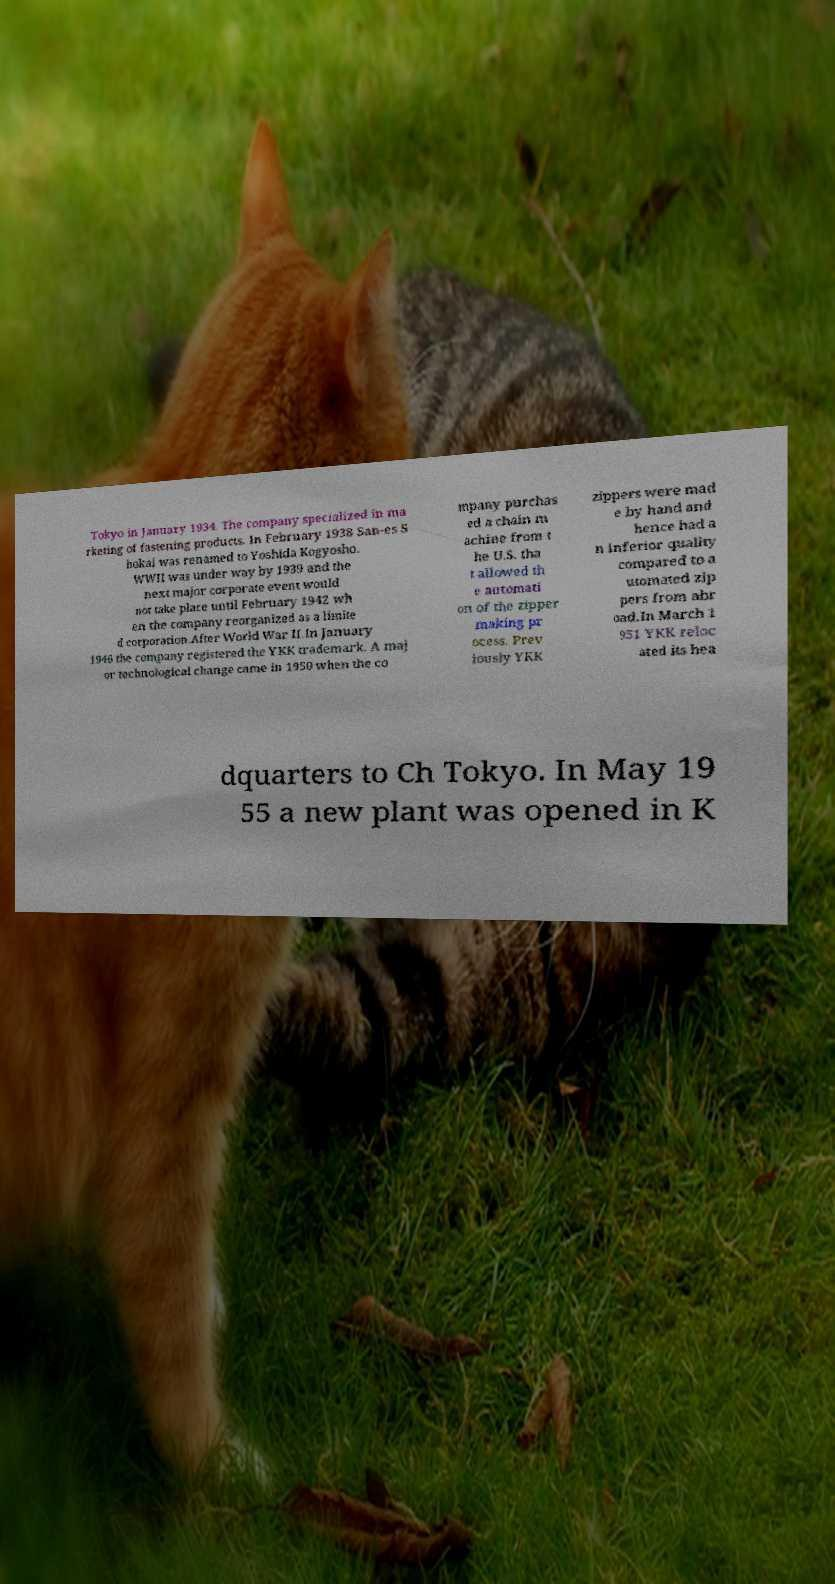Please read and relay the text visible in this image. What does it say? Tokyo in January 1934. The company specialized in ma rketing of fastening products. In February 1938 San-es S hokai was renamed to Yoshida Kogyosho. WWII was under way by 1939 and the next major corporate event would not take place until February 1942 wh en the company reorganized as a limite d corporation.After World War II.In January 1946 the company registered the YKK trademark. A maj or technological change came in 1950 when the co mpany purchas ed a chain m achine from t he U.S. tha t allowed th e automati on of the zipper making pr ocess. Prev iously YKK zippers were mad e by hand and hence had a n inferior quality compared to a utomated zip pers from abr oad.In March 1 951 YKK reloc ated its hea dquarters to Ch Tokyo. In May 19 55 a new plant was opened in K 